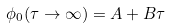<formula> <loc_0><loc_0><loc_500><loc_500>\phi _ { 0 } ( \tau \rightarrow \infty ) = A + B \tau</formula> 